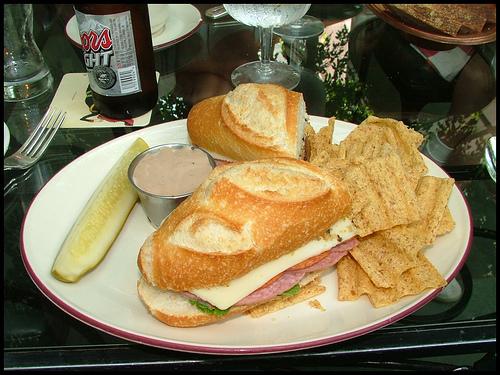Does this meal look disgusting?
Concise answer only. No. What is on the plate?
Quick response, please. Sandwich, chips, dip, and pickle. Is this sandwich sitting on a plate?
Write a very short answer. Yes. 